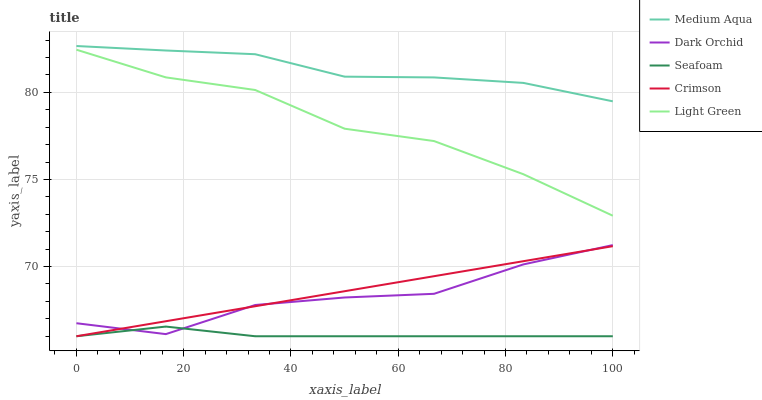Does Seafoam have the minimum area under the curve?
Answer yes or no. Yes. Does Medium Aqua have the maximum area under the curve?
Answer yes or no. Yes. Does Light Green have the minimum area under the curve?
Answer yes or no. No. Does Light Green have the maximum area under the curve?
Answer yes or no. No. Is Crimson the smoothest?
Answer yes or no. Yes. Is Dark Orchid the roughest?
Answer yes or no. Yes. Is Light Green the smoothest?
Answer yes or no. No. Is Light Green the roughest?
Answer yes or no. No. Does Crimson have the lowest value?
Answer yes or no. Yes. Does Light Green have the lowest value?
Answer yes or no. No. Does Medium Aqua have the highest value?
Answer yes or no. Yes. Does Light Green have the highest value?
Answer yes or no. No. Is Dark Orchid less than Medium Aqua?
Answer yes or no. Yes. Is Medium Aqua greater than Light Green?
Answer yes or no. Yes. Does Crimson intersect Dark Orchid?
Answer yes or no. Yes. Is Crimson less than Dark Orchid?
Answer yes or no. No. Is Crimson greater than Dark Orchid?
Answer yes or no. No. Does Dark Orchid intersect Medium Aqua?
Answer yes or no. No. 